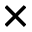<formula> <loc_0><loc_0><loc_500><loc_500>\times</formula> 